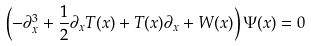Convert formula to latex. <formula><loc_0><loc_0><loc_500><loc_500>\left ( - \partial _ { x } ^ { 3 } + \frac { 1 } { 2 } \partial _ { x } T ( x ) + T ( x ) \partial _ { x } + W ( x ) \right ) \Psi ( x ) = 0</formula> 